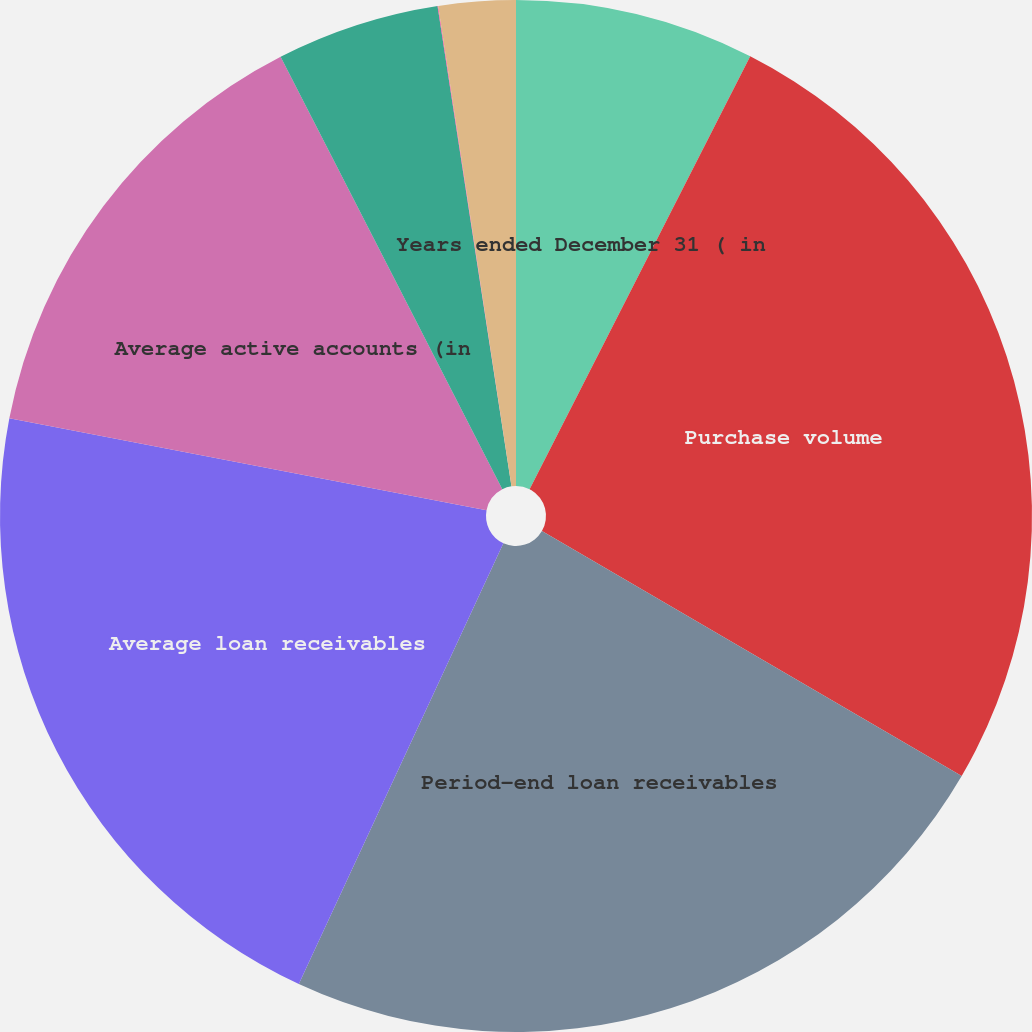<chart> <loc_0><loc_0><loc_500><loc_500><pie_chart><fcel>Years ended December 31 ( in<fcel>Purchase volume<fcel>Period-end loan receivables<fcel>Average loan receivables<fcel>Average active accounts (in<fcel>Interest and fees on loans<fcel>Retailer share arrangements<fcel>Other income<nl><fcel>7.5%<fcel>25.91%<fcel>23.51%<fcel>21.12%<fcel>14.43%<fcel>5.11%<fcel>0.02%<fcel>2.41%<nl></chart> 